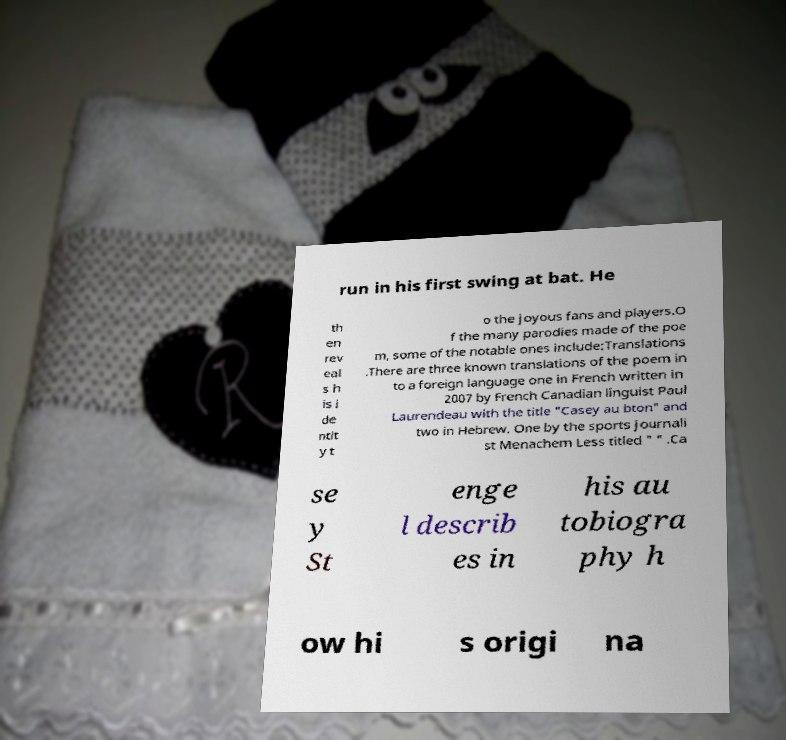Could you assist in decoding the text presented in this image and type it out clearly? run in his first swing at bat. He th en rev eal s h is i de ntit y t o the joyous fans and players.O f the many parodies made of the poe m, some of the notable ones include:Translations .There are three known translations of the poem in to a foreign language one in French written in 2007 by French Canadian linguist Paul Laurendeau with the title "Casey au bton" and two in Hebrew. One by the sports journali st Menachem Less titled " " .Ca se y St enge l describ es in his au tobiogra phy h ow hi s origi na 